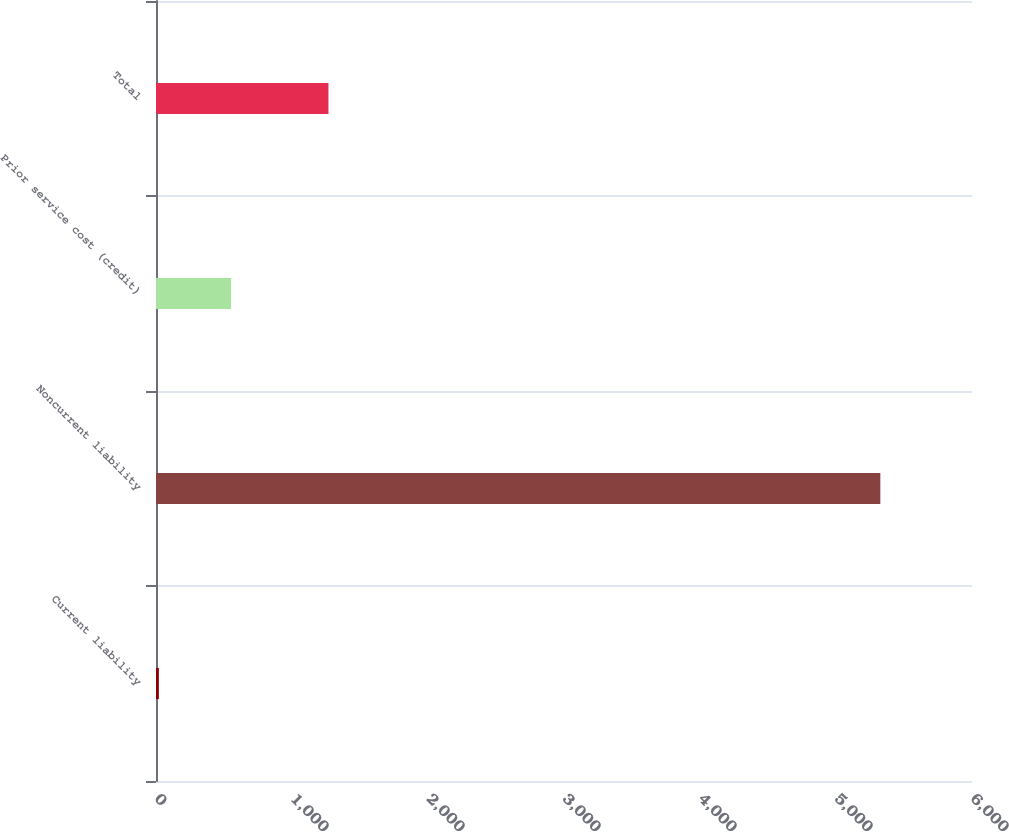<chart> <loc_0><loc_0><loc_500><loc_500><bar_chart><fcel>Current liability<fcel>Noncurrent liability<fcel>Prior service cost (credit)<fcel>Total<nl><fcel>21<fcel>5326<fcel>551.5<fcel>1268<nl></chart> 